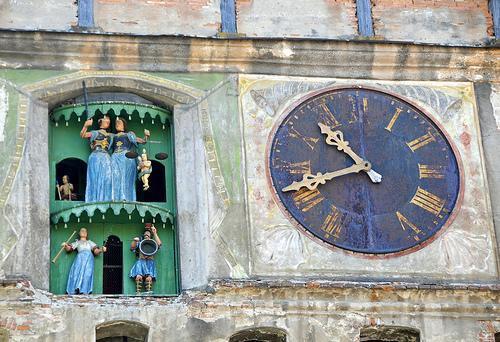How many clocks are pictured?
Give a very brief answer. 1. 